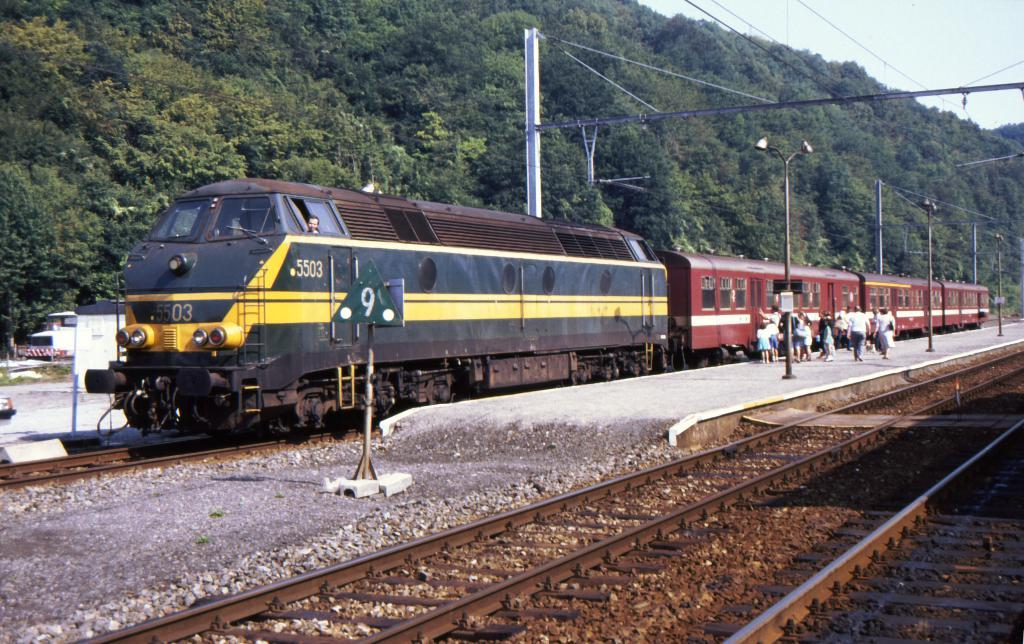<image>
Present a compact description of the photo's key features. Train number 5503 stops to pick up passengers. 